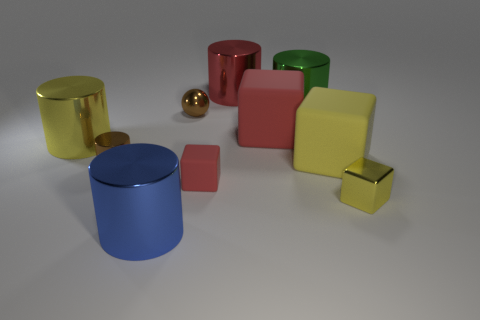There is a green object; is it the same shape as the brown thing that is in front of the tiny shiny ball?
Offer a very short reply. Yes. Do the brown thing that is left of the blue object and the red shiny thing have the same shape?
Your answer should be very brief. Yes. What number of cylinders are on the right side of the big red shiny object and in front of the yellow rubber block?
Offer a terse response. 0. What number of other things are the same size as the brown cylinder?
Provide a short and direct response. 3. Are there an equal number of yellow metal things that are right of the brown sphere and yellow metal cubes?
Your answer should be very brief. Yes. There is a big block that is behind the yellow metallic cylinder; is its color the same as the cylinder in front of the tiny rubber object?
Make the answer very short. No. There is a red object that is both behind the brown metal cylinder and in front of the green thing; what is its material?
Offer a very short reply. Rubber. The shiny cube has what color?
Provide a succinct answer. Yellow. What number of other objects are there of the same shape as the green metal thing?
Your answer should be very brief. 4. Are there an equal number of big yellow matte objects that are to the right of the shiny block and brown objects on the left side of the brown sphere?
Your answer should be compact. No. 